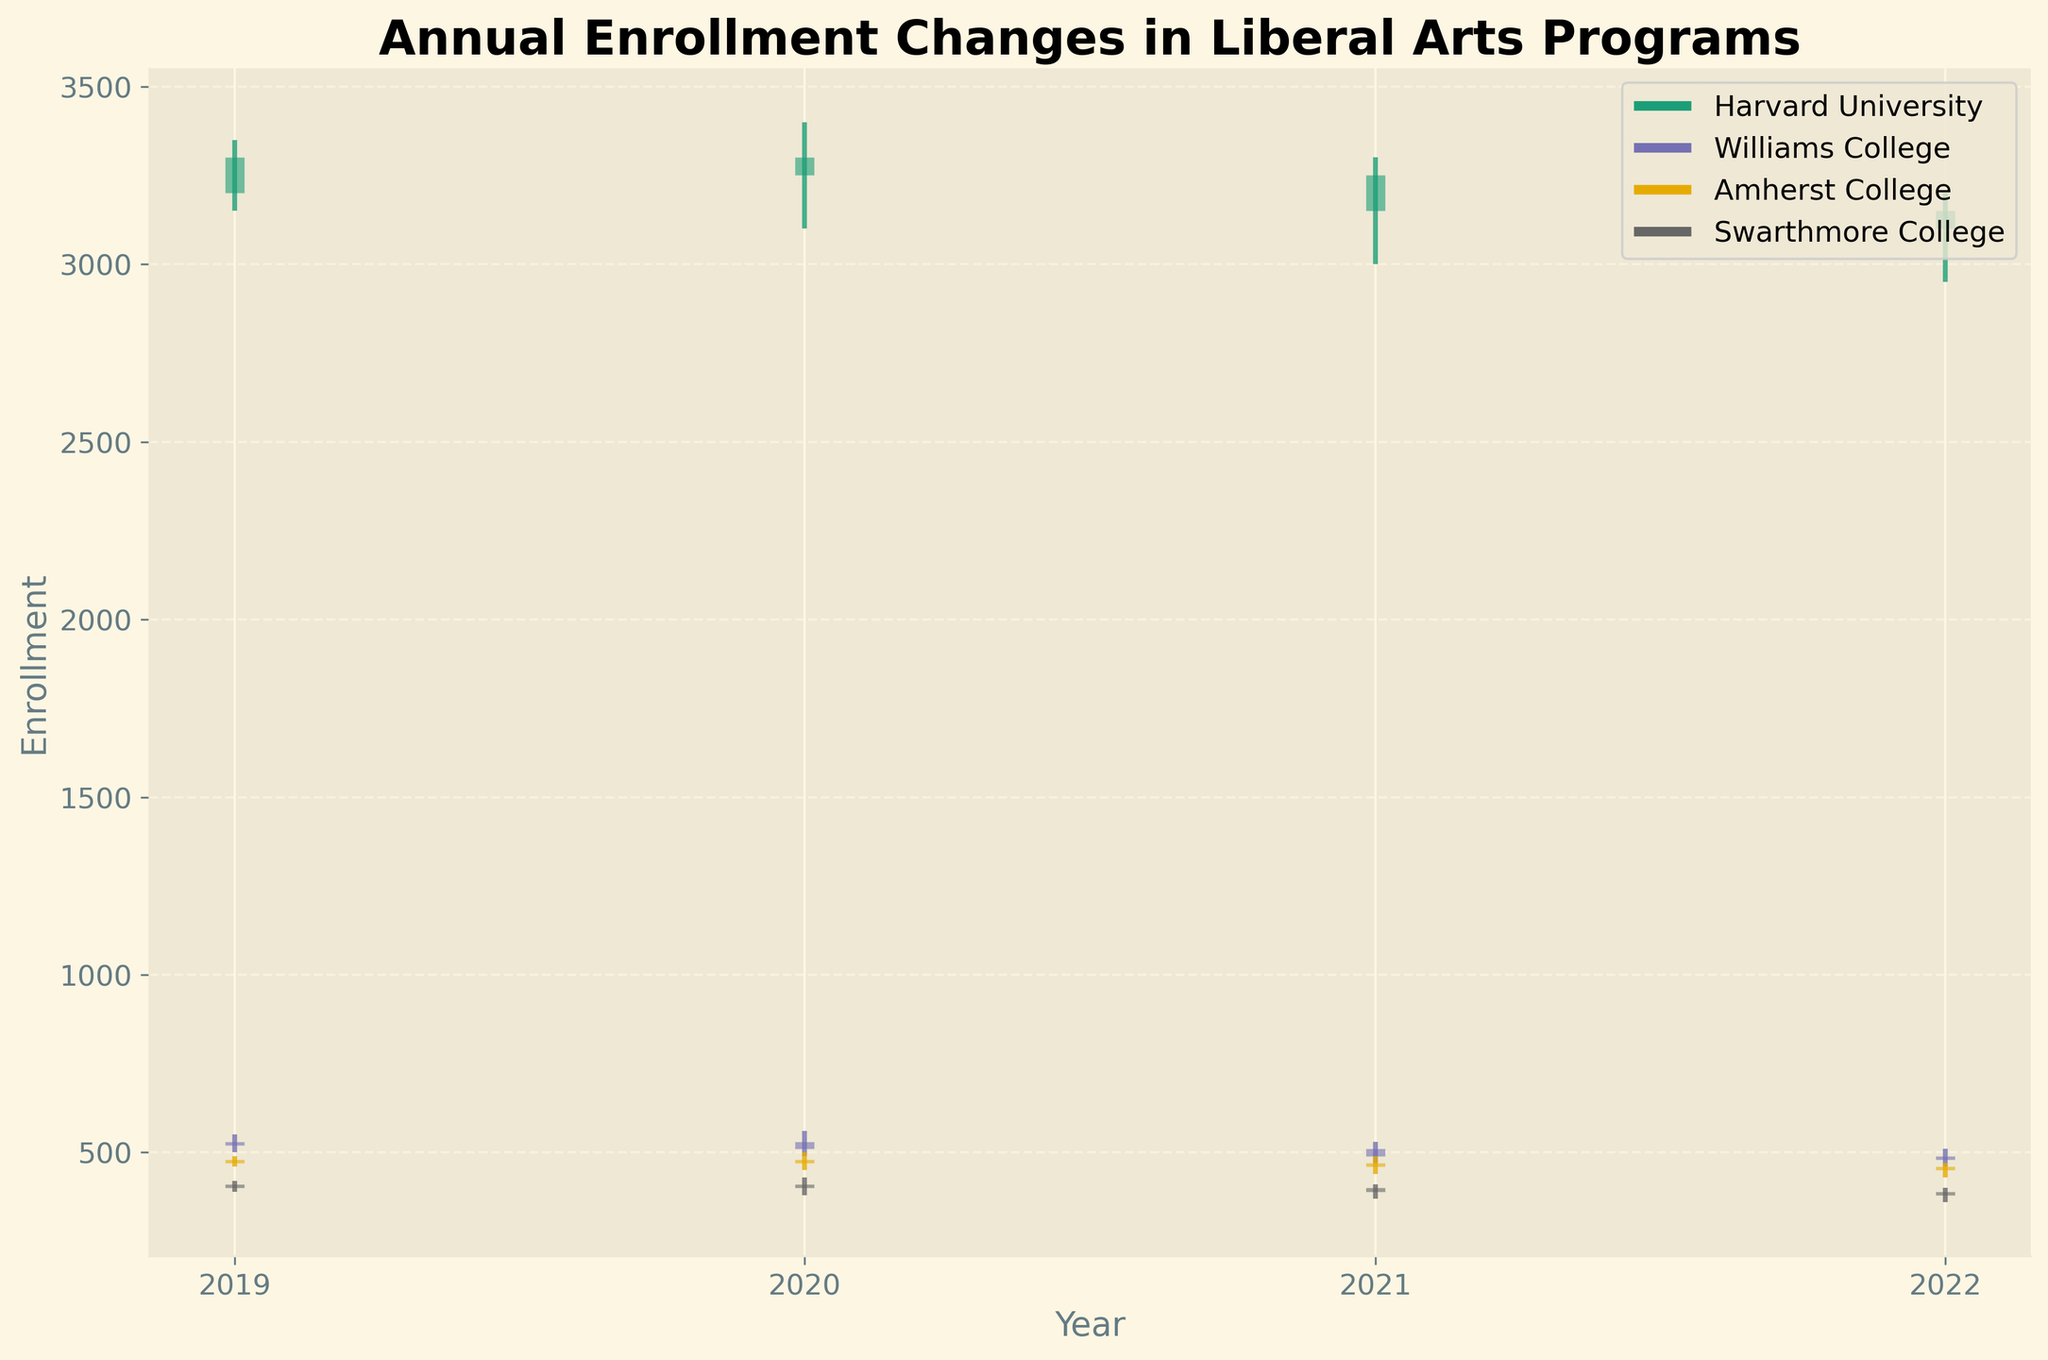What's the title of the chart? The title is usually placed at the top of the chart and is designed to inform the viewer of the nature of the data being presented.
Answer: Annual Enrollment Changes in Liberal Arts Programs How many institutions are represented in the chart? The chart's legend usually lists all the data series represented, where each institution should have a distinct color. Count the number of items in the legend.
Answer: 4 Which institution had the highest enrollment high in 2019? Look for the year 2019 and identify which institution had the highest value in the high bar on the OHLC chart.
Answer: Harvard University What was the enrollment close for Swarthmore College in 2022? Find Swarthmore College for the year 2022 and check the final value represented on the OHLC chart.
Answer: 380 What is the overall trend in Harvard University's enrollment from 2019 to 2022? Trace the close values for Harvard University across the years 2019, 2020, 2021, and 2022 to see how enrollment numbers have changed over time.
Answer: Generally Decreasing Which institution experienced the largest drop in enrollment close between 2019 and 2022? Calculate the difference between the 2019 and 2022 close values for each institution, and identify the one with the largest negative change. Detailed steps: 
1. Harvard University: 3300 - 3100 = 200
2. Williams College: 530 - 480 = 50
3. Amherst College: 480 - 450 = 30
4. Swarthmore College: 410 - 380 = 30.
Answer: Harvard University How did Williams College's enrollment close for 2020 compare to its enrollment open for 2019? Find the close value for Williams College in 2020 and compare it to the open value in 2019 from the OHLC chart. Detailed steps:
1. Close value for Williams College in 2020 is 510.
2. Open value for Williams College in 2019 is 520.
3. Compare 510 to 520.
Answer: Lower For Amherst College, what was the difference between the highest enrollment point in 2020 and the lowest enrollment point in 2021? Identify Amherst College's high in 2020 and low in 2021 from the OHLC chart and calculate the difference. Detailed steps:
1. High value in 2020 is 500.
2. Low value in 2021 is 440.
3. Difference = 500 - 440.
Answer: 60 Compare the enrollment volatility of Swarthmore College in 2019 and 2022. Which year had the greater range between high and low values? Calculate the range (High - Low) for Swarthmore College in both years and compare them. Detailed steps:
1. 2019: High = 420, Low = 390, Range = 420 - 390 = 30.
2. 2022: High = 400, Low = 360, Range = 400 - 360 = 40.
3. Compare 30 and 40.
Answer: 2022 By how much did the Williams College enrollment close value change from 2021 to 2022? Check the close values for Williams College in 2021 and 2022 and calculate the difference. Detailed steps:
1. Close value in 2021 = 490.
2. Close value in 2022 = 480.
3. Difference = 490 - 480.
Answer: 10 